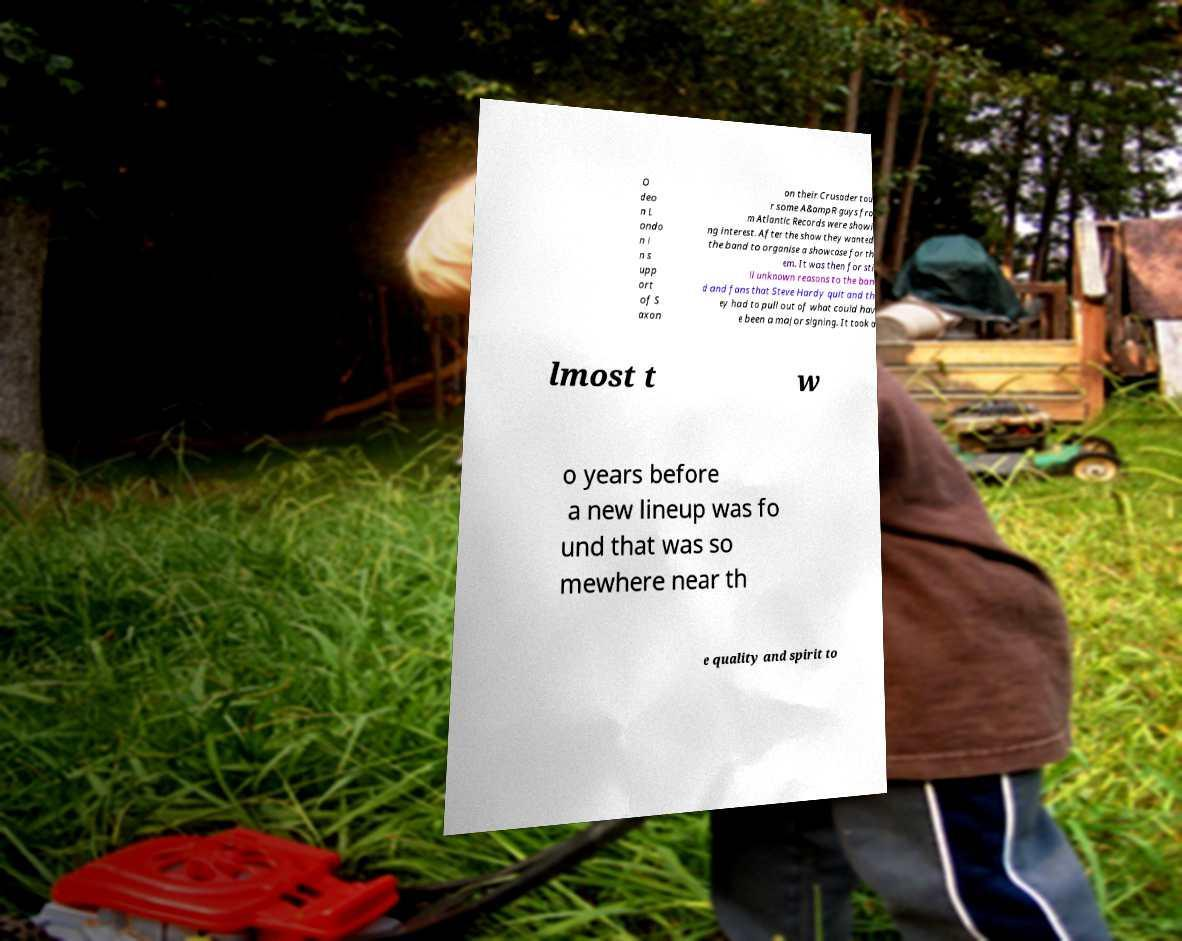There's text embedded in this image that I need extracted. Can you transcribe it verbatim? O deo n L ondo n i n s upp ort of S axon on their Crusader tou r some A&ampR guys fro m Atlantic Records were showi ng interest. After the show they wanted the band to organise a showcase for th em. It was then for sti ll unknown reasons to the ban d and fans that Steve Hardy quit and th ey had to pull out of what could hav e been a major signing. It took a lmost t w o years before a new lineup was fo und that was so mewhere near th e quality and spirit to 